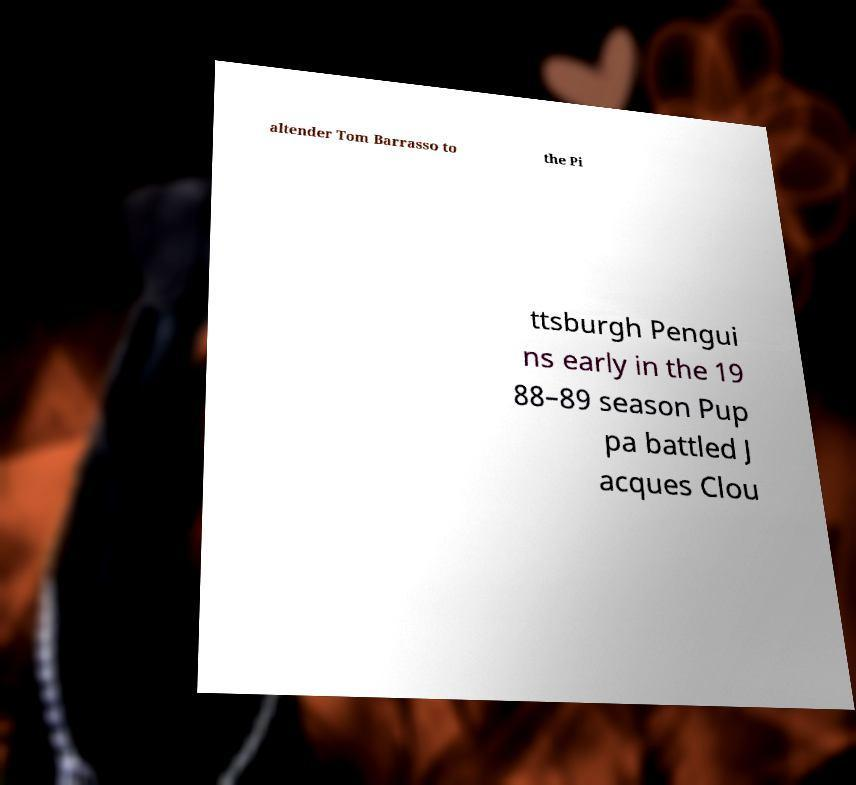Can you accurately transcribe the text from the provided image for me? altender Tom Barrasso to the Pi ttsburgh Pengui ns early in the 19 88–89 season Pup pa battled J acques Clou 